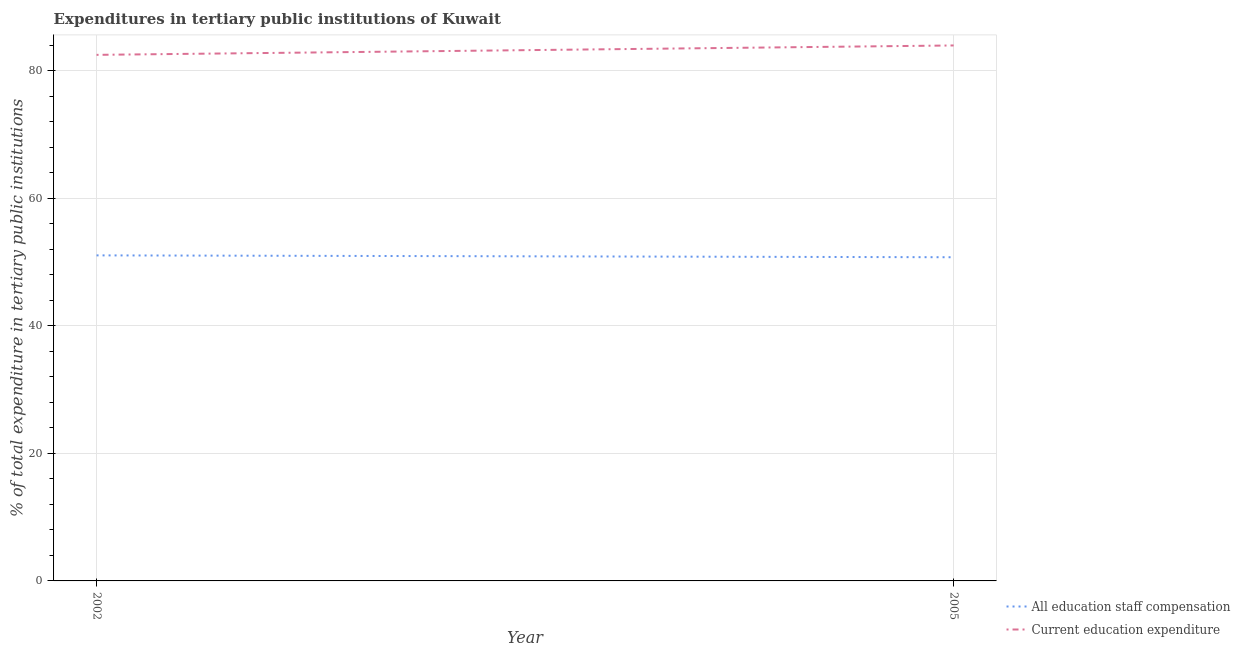How many different coloured lines are there?
Provide a succinct answer. 2. Is the number of lines equal to the number of legend labels?
Your answer should be very brief. Yes. What is the expenditure in education in 2002?
Provide a succinct answer. 82.52. Across all years, what is the maximum expenditure in staff compensation?
Your answer should be very brief. 51.07. Across all years, what is the minimum expenditure in education?
Provide a short and direct response. 82.52. What is the total expenditure in staff compensation in the graph?
Keep it short and to the point. 101.85. What is the difference between the expenditure in staff compensation in 2002 and that in 2005?
Keep it short and to the point. 0.29. What is the difference between the expenditure in staff compensation in 2002 and the expenditure in education in 2005?
Your answer should be very brief. -32.93. What is the average expenditure in staff compensation per year?
Keep it short and to the point. 50.92. In the year 2005, what is the difference between the expenditure in staff compensation and expenditure in education?
Your answer should be compact. -33.22. What is the ratio of the expenditure in staff compensation in 2002 to that in 2005?
Offer a very short reply. 1.01. In how many years, is the expenditure in staff compensation greater than the average expenditure in staff compensation taken over all years?
Offer a very short reply. 1. Is the expenditure in education strictly greater than the expenditure in staff compensation over the years?
Give a very brief answer. Yes. Is the expenditure in education strictly less than the expenditure in staff compensation over the years?
Make the answer very short. No. How many lines are there?
Keep it short and to the point. 2. How many years are there in the graph?
Your answer should be compact. 2. Does the graph contain any zero values?
Provide a succinct answer. No. Does the graph contain grids?
Offer a very short reply. Yes. Where does the legend appear in the graph?
Provide a succinct answer. Bottom right. How many legend labels are there?
Your answer should be compact. 2. How are the legend labels stacked?
Keep it short and to the point. Vertical. What is the title of the graph?
Give a very brief answer. Expenditures in tertiary public institutions of Kuwait. Does "Private creditors" appear as one of the legend labels in the graph?
Offer a very short reply. No. What is the label or title of the Y-axis?
Ensure brevity in your answer.  % of total expenditure in tertiary public institutions. What is the % of total expenditure in tertiary public institutions in All education staff compensation in 2002?
Give a very brief answer. 51.07. What is the % of total expenditure in tertiary public institutions of Current education expenditure in 2002?
Provide a succinct answer. 82.52. What is the % of total expenditure in tertiary public institutions of All education staff compensation in 2005?
Your answer should be very brief. 50.78. What is the % of total expenditure in tertiary public institutions in Current education expenditure in 2005?
Offer a very short reply. 84. Across all years, what is the maximum % of total expenditure in tertiary public institutions in All education staff compensation?
Give a very brief answer. 51.07. Across all years, what is the maximum % of total expenditure in tertiary public institutions in Current education expenditure?
Your response must be concise. 84. Across all years, what is the minimum % of total expenditure in tertiary public institutions of All education staff compensation?
Ensure brevity in your answer.  50.78. Across all years, what is the minimum % of total expenditure in tertiary public institutions in Current education expenditure?
Provide a succinct answer. 82.52. What is the total % of total expenditure in tertiary public institutions of All education staff compensation in the graph?
Provide a succinct answer. 101.85. What is the total % of total expenditure in tertiary public institutions in Current education expenditure in the graph?
Offer a very short reply. 166.52. What is the difference between the % of total expenditure in tertiary public institutions in All education staff compensation in 2002 and that in 2005?
Your answer should be very brief. 0.29. What is the difference between the % of total expenditure in tertiary public institutions of Current education expenditure in 2002 and that in 2005?
Make the answer very short. -1.47. What is the difference between the % of total expenditure in tertiary public institutions of All education staff compensation in 2002 and the % of total expenditure in tertiary public institutions of Current education expenditure in 2005?
Your answer should be very brief. -32.93. What is the average % of total expenditure in tertiary public institutions of All education staff compensation per year?
Your response must be concise. 50.92. What is the average % of total expenditure in tertiary public institutions of Current education expenditure per year?
Provide a short and direct response. 83.26. In the year 2002, what is the difference between the % of total expenditure in tertiary public institutions of All education staff compensation and % of total expenditure in tertiary public institutions of Current education expenditure?
Provide a short and direct response. -31.45. In the year 2005, what is the difference between the % of total expenditure in tertiary public institutions of All education staff compensation and % of total expenditure in tertiary public institutions of Current education expenditure?
Give a very brief answer. -33.22. What is the ratio of the % of total expenditure in tertiary public institutions of Current education expenditure in 2002 to that in 2005?
Keep it short and to the point. 0.98. What is the difference between the highest and the second highest % of total expenditure in tertiary public institutions of All education staff compensation?
Provide a succinct answer. 0.29. What is the difference between the highest and the second highest % of total expenditure in tertiary public institutions of Current education expenditure?
Ensure brevity in your answer.  1.47. What is the difference between the highest and the lowest % of total expenditure in tertiary public institutions of All education staff compensation?
Your response must be concise. 0.29. What is the difference between the highest and the lowest % of total expenditure in tertiary public institutions of Current education expenditure?
Provide a succinct answer. 1.47. 